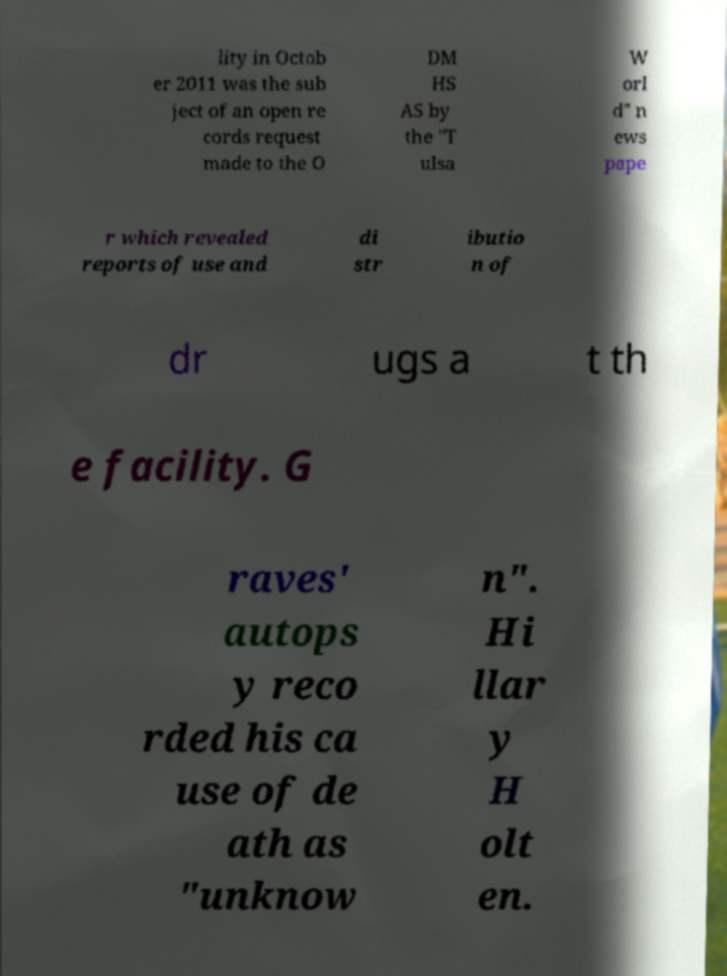For documentation purposes, I need the text within this image transcribed. Could you provide that? lity in Octob er 2011 was the sub ject of an open re cords request made to the O DM HS AS by the "T ulsa W orl d" n ews pape r which revealed reports of use and di str ibutio n of dr ugs a t th e facility. G raves' autops y reco rded his ca use of de ath as "unknow n". Hi llar y H olt en. 